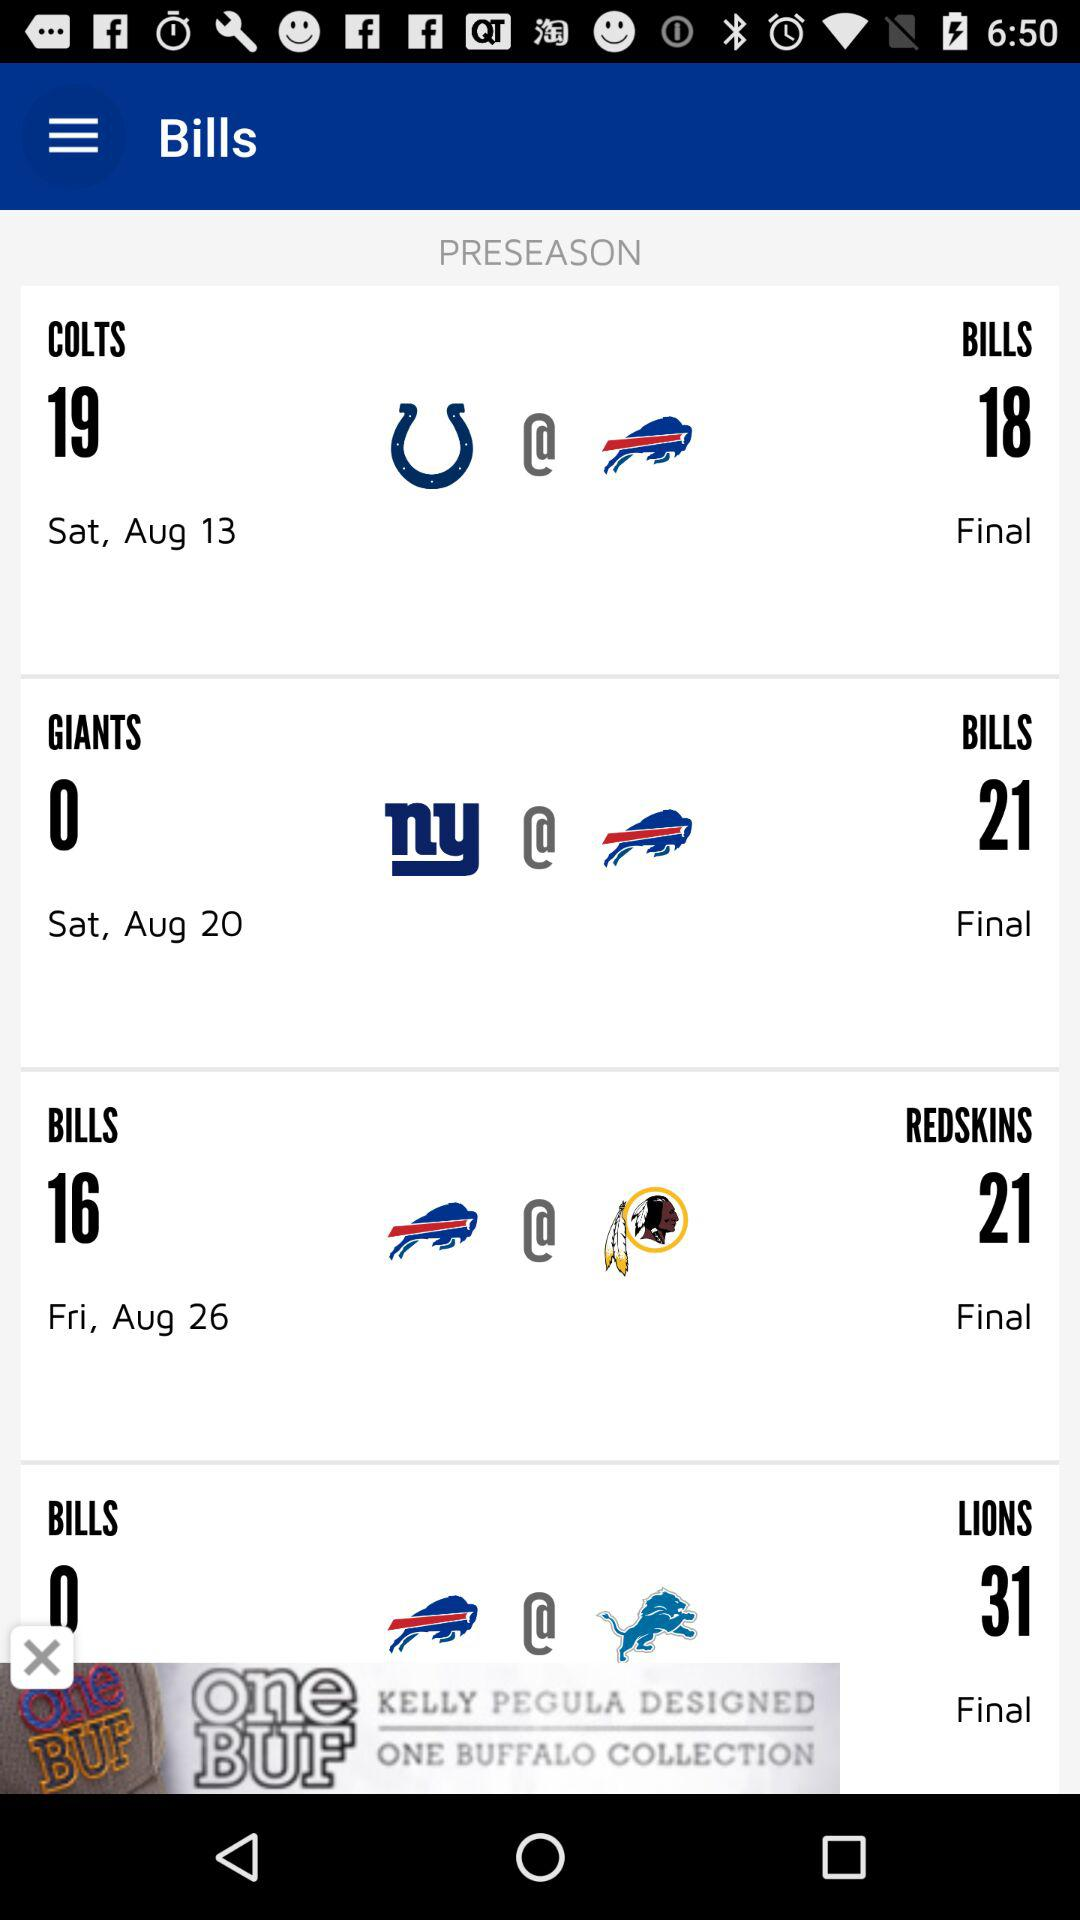What is the day on August 26? The day is Friday. 